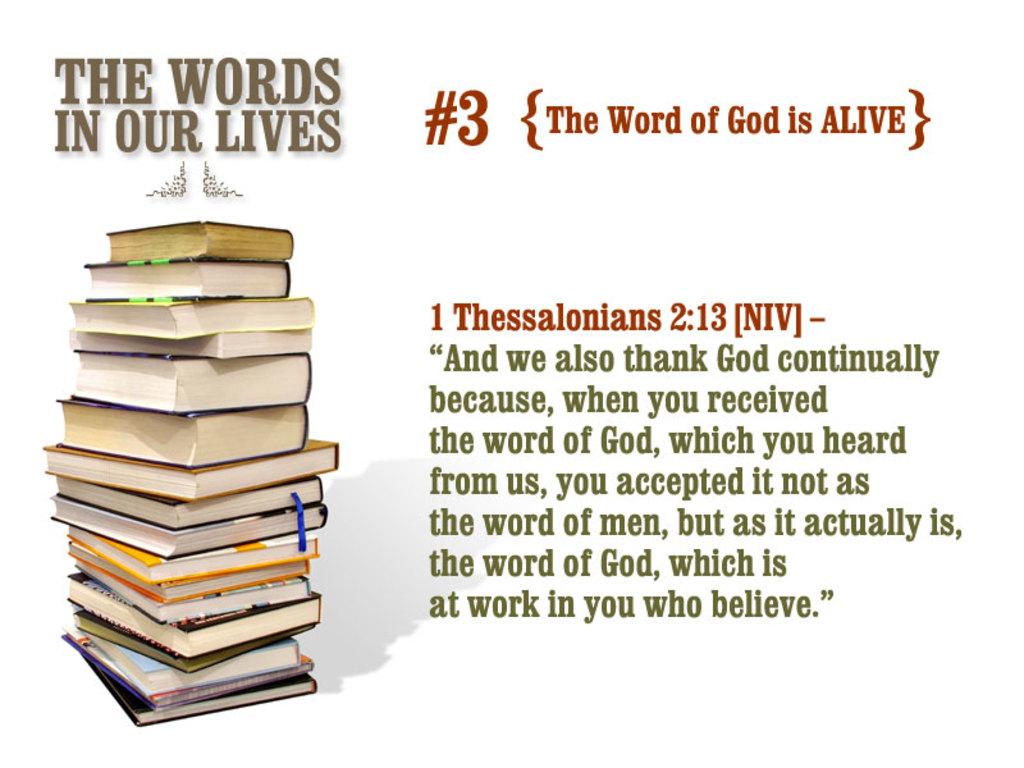What does it say the word of god is?
Keep it short and to the point. Alive. What book of the bible is the verse from?
Provide a succinct answer. Thessalonians. 